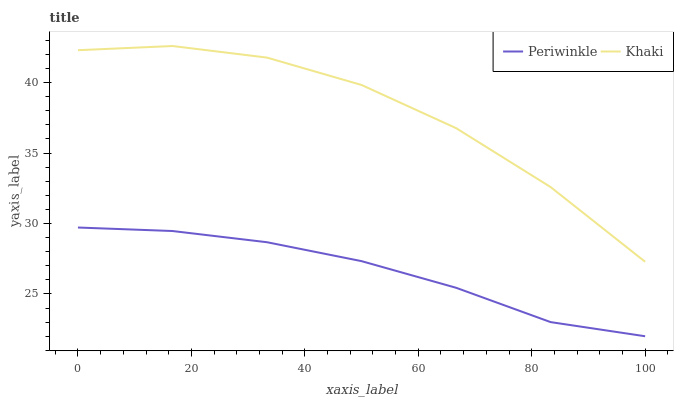Does Periwinkle have the minimum area under the curve?
Answer yes or no. Yes. Does Khaki have the maximum area under the curve?
Answer yes or no. Yes. Does Periwinkle have the maximum area under the curve?
Answer yes or no. No. Is Periwinkle the smoothest?
Answer yes or no. Yes. Is Khaki the roughest?
Answer yes or no. Yes. Is Periwinkle the roughest?
Answer yes or no. No. Does Periwinkle have the lowest value?
Answer yes or no. Yes. Does Khaki have the highest value?
Answer yes or no. Yes. Does Periwinkle have the highest value?
Answer yes or no. No. Is Periwinkle less than Khaki?
Answer yes or no. Yes. Is Khaki greater than Periwinkle?
Answer yes or no. Yes. Does Periwinkle intersect Khaki?
Answer yes or no. No. 